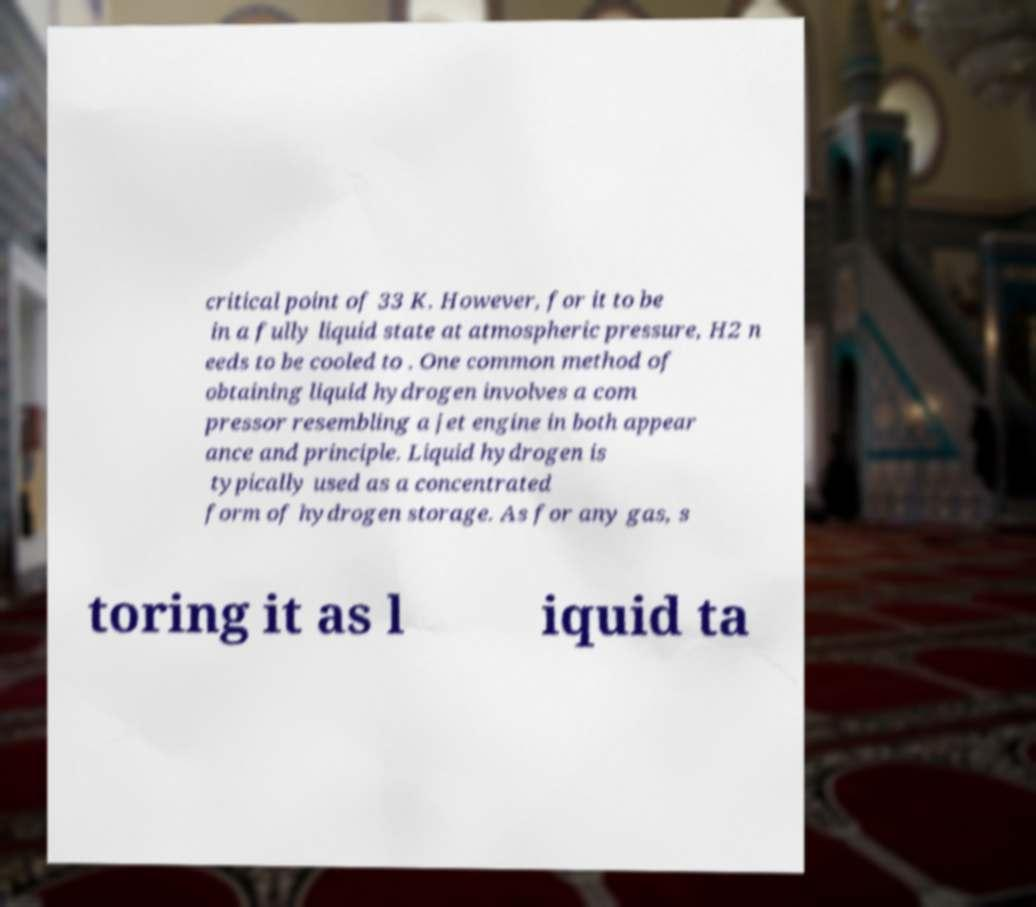Can you read and provide the text displayed in the image?This photo seems to have some interesting text. Can you extract and type it out for me? critical point of 33 K. However, for it to be in a fully liquid state at atmospheric pressure, H2 n eeds to be cooled to . One common method of obtaining liquid hydrogen involves a com pressor resembling a jet engine in both appear ance and principle. Liquid hydrogen is typically used as a concentrated form of hydrogen storage. As for any gas, s toring it as l iquid ta 